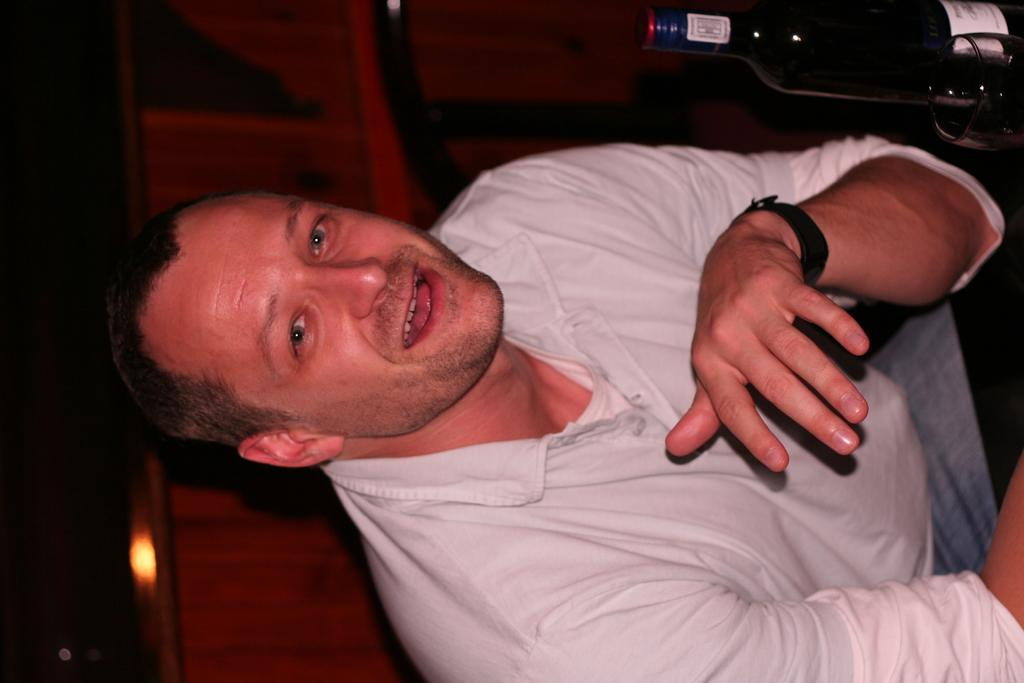Who is present in the image? There is a man in the image. What is the man wearing? The man is wearing a white T-shirt. What can be seen at the top of the image? There is a bottle at the top of the image. What type of object is visible in the background of the image? There is a wooden block in the background of the image. What type of cars can be seen in the image? There are no cars present in the image. What is the man doing in the mine in the image? There is no mine or any indication of mining activity in the image; it features a man wearing a white T-shirt and a bottle at the top. 